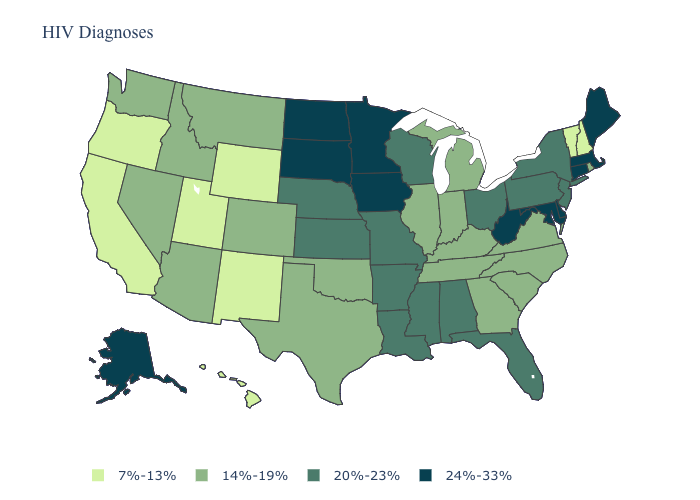Does Indiana have the highest value in the USA?
Concise answer only. No. What is the lowest value in the USA?
Keep it brief. 7%-13%. Name the states that have a value in the range 14%-19%?
Answer briefly. Arizona, Colorado, Georgia, Idaho, Illinois, Indiana, Kentucky, Michigan, Montana, Nevada, North Carolina, Oklahoma, Rhode Island, South Carolina, Tennessee, Texas, Virginia, Washington. What is the lowest value in the MidWest?
Be succinct. 14%-19%. Name the states that have a value in the range 14%-19%?
Give a very brief answer. Arizona, Colorado, Georgia, Idaho, Illinois, Indiana, Kentucky, Michigan, Montana, Nevada, North Carolina, Oklahoma, Rhode Island, South Carolina, Tennessee, Texas, Virginia, Washington. What is the value of Louisiana?
Short answer required. 20%-23%. Name the states that have a value in the range 20%-23%?
Keep it brief. Alabama, Arkansas, Florida, Kansas, Louisiana, Mississippi, Missouri, Nebraska, New Jersey, New York, Ohio, Pennsylvania, Wisconsin. Is the legend a continuous bar?
Give a very brief answer. No. Name the states that have a value in the range 7%-13%?
Quick response, please. California, Hawaii, New Hampshire, New Mexico, Oregon, Utah, Vermont, Wyoming. Is the legend a continuous bar?
Quick response, please. No. Among the states that border Missouri , which have the lowest value?
Give a very brief answer. Illinois, Kentucky, Oklahoma, Tennessee. What is the value of Massachusetts?
Write a very short answer. 24%-33%. Name the states that have a value in the range 20%-23%?
Quick response, please. Alabama, Arkansas, Florida, Kansas, Louisiana, Mississippi, Missouri, Nebraska, New Jersey, New York, Ohio, Pennsylvania, Wisconsin. What is the value of Iowa?
Short answer required. 24%-33%. How many symbols are there in the legend?
Keep it brief. 4. 